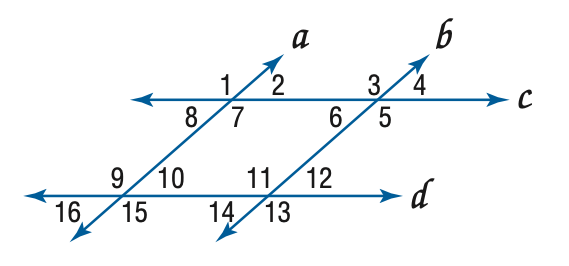Answer the mathemtical geometry problem and directly provide the correct option letter.
Question: In the figure, a \parallel b, c \parallel d, and m \angle 4 = 57. Find the measure of \angle 5.
Choices: A: 57 B: 113 C: 123 D: 133 C 